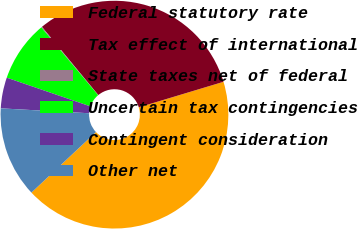Convert chart to OTSL. <chart><loc_0><loc_0><loc_500><loc_500><pie_chart><fcel>Federal statutory rate<fcel>Tax effect of international<fcel>State taxes net of federal<fcel>Uncertain tax contingencies<fcel>Contingent consideration<fcel>Other net<nl><fcel>42.66%<fcel>31.33%<fcel>0.12%<fcel>8.63%<fcel>4.38%<fcel>12.88%<nl></chart> 